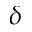<formula> <loc_0><loc_0><loc_500><loc_500>\delta</formula> 